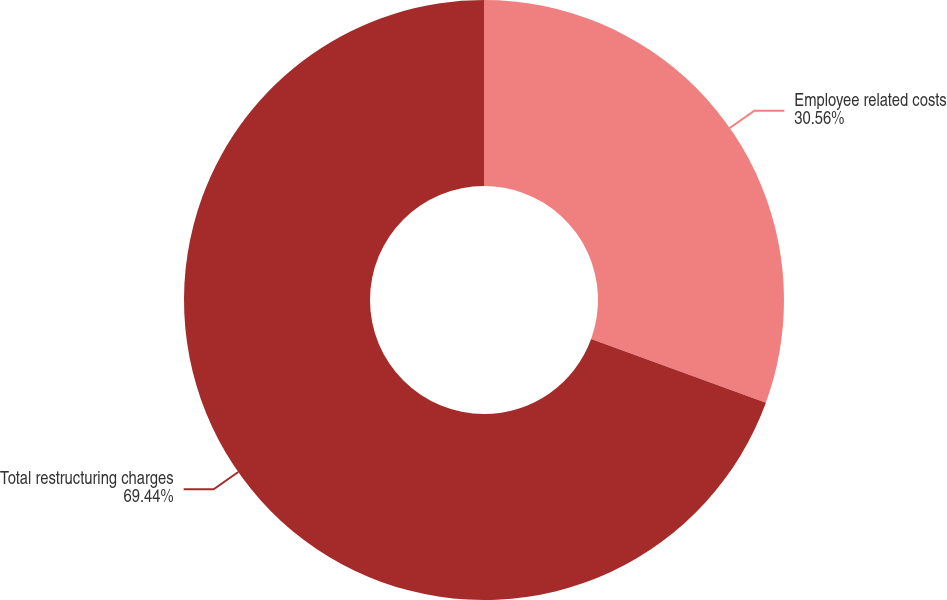<chart> <loc_0><loc_0><loc_500><loc_500><pie_chart><fcel>Employee related costs<fcel>Total restructuring charges<nl><fcel>30.56%<fcel>69.44%<nl></chart> 